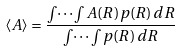Convert formula to latex. <formula><loc_0><loc_0><loc_500><loc_500>\langle A \rangle = \frac { \int \dots \int A ( { R } ) p ( { R } ) \, d { R } } { \int \dots \int p ( { R } ) \, d { R } }</formula> 